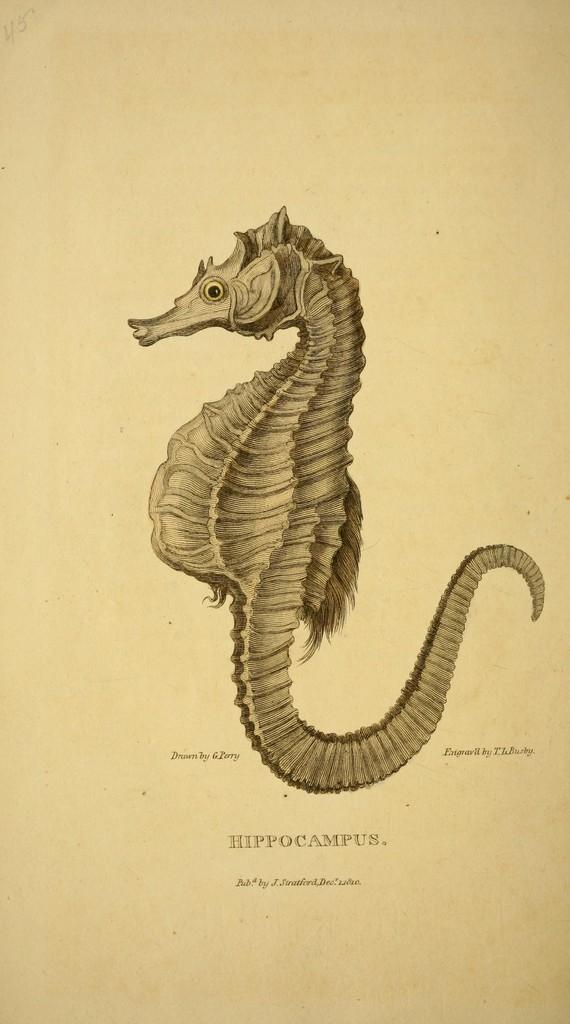What is the main subject of the image? The main subject of the image is a picture of a seahorse. What else can be seen in the image besides the seahorse? There is text on a paper in the image. What type of butter is being used to write the text on the paper in the image? There is no butter present in the image; the text is written on a paper without any butter. 